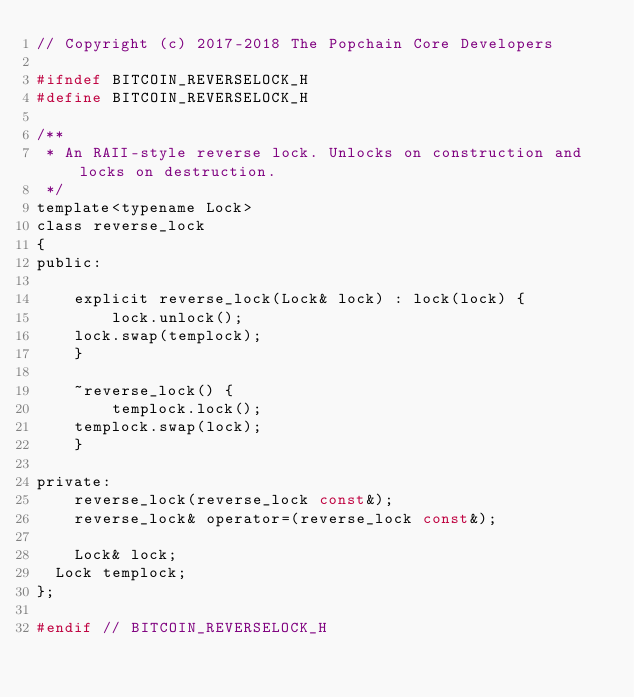Convert code to text. <code><loc_0><loc_0><loc_500><loc_500><_C_>// Copyright (c) 2017-2018 The Popchain Core Developers

#ifndef BITCOIN_REVERSELOCK_H
#define BITCOIN_REVERSELOCK_H

/**
 * An RAII-style reverse lock. Unlocks on construction and locks on destruction.
 */
template<typename Lock>
class reverse_lock
{
public:

    explicit reverse_lock(Lock& lock) : lock(lock) {
        lock.unlock();
		lock.swap(templock);
    }

    ~reverse_lock() {
        templock.lock();
		templock.swap(lock);
    }

private:
    reverse_lock(reverse_lock const&);
    reverse_lock& operator=(reverse_lock const&);

    Lock& lock;
	Lock templock;
};

#endif // BITCOIN_REVERSELOCK_H
</code> 